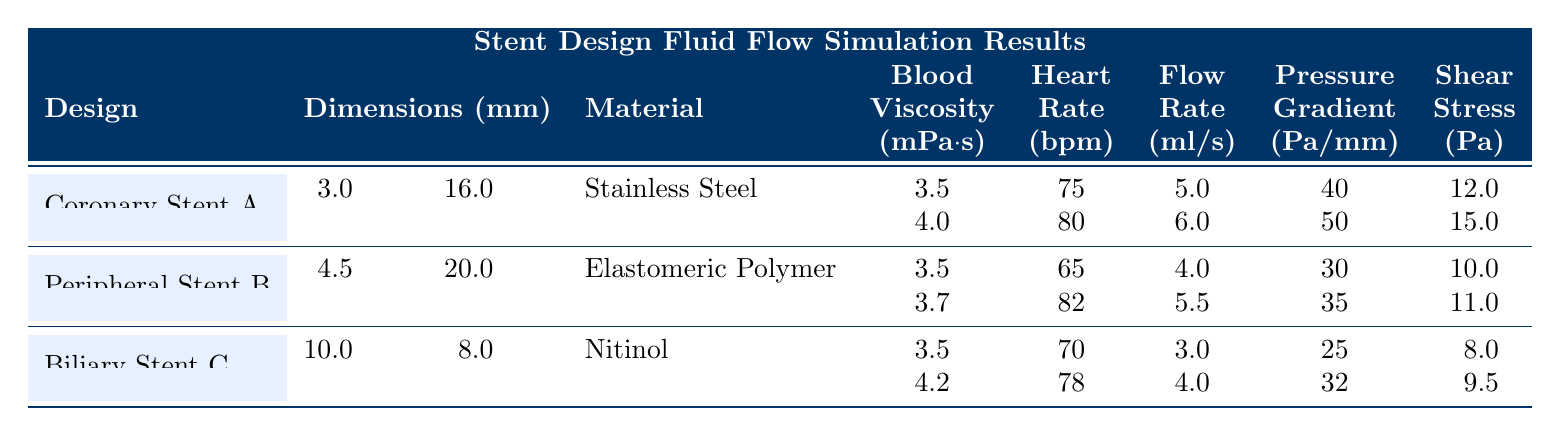What is the diameter of Biliary Stent C? The diameter of Biliary Stent C is listed in the dimensions section of the table, which shows the dimensions for each stent design. Specifically, it states "diameter_mm: 10.0" for Biliary Stent C.
Answer: 10.0 mm What material is used for Peripheral Stent B? Peripheral Stent B has its material specified as "Elastomeric Polymer" in the material column of the table.
Answer: Elastomeric Polymer What is the flow rate for Coronary Stent A under a blood viscosity of 4.0 mPa·s? Coronary Stent A has a condition listed with a blood viscosity of 4.0 mPa·s, with the flow rate being shown in the corresponding row. It states the flow rate as "6.0 ml/s."
Answer: 6.0 ml/s What is the average shear stress for all stent designs? To find the average shear stress, we need to sum the shear stress values across all conditions and divide by the number of conditions. The total shear stress values are 12.0 + 15.0 + 10.0 + 11.0 + 8.0 + 9.5 = 66.5 and there are 6 conditions. Thus, the average shear stress is 66.5 / 6 = 11.08.
Answer: 11.08 Pa Is the heart rate for the second condition of Peripheral Stent B higher than 75 bpm? The heart rate for the second condition of Peripheral Stent B is 82 bpm, which can be compared to 75 bpm from the question. Since 82 is greater than 75, the answer is yes.
Answer: Yes Which stent design has the highest pressure gradient? To determine the highest pressure gradient, we need to examine the pressure gradient values for each design. The values are 40, 50 (Coronary Stent A), 30, 35 (Peripheral Stent B), and 25, 32 (Biliary Stent C). The maximum value among these is 50 for Coronary Stent A.
Answer: Coronary Stent A How many different blood viscosity conditions are tested for Biliary Stent C? Biliary Stent C has two conditions listed in the table, each with its respective blood viscosity values. This indicates that two different viscosity conditions were tested.
Answer: 2 What is the pressure gradient for the first condition of Coronary Stent A? The first condition for Coronary Stent A states that the pressure gradient is "40 Pa/mm," which can be directly referenced from the corresponding entry in the table.
Answer: 40 Pa/mm Does Peripheral Stent B have a higher shear stress in its second condition than the first? The shear stress in the first condition for Peripheral Stent B is 10.0 Pa while in the second condition it is 11.0 Pa. Since 11.0 is greater than 10.0, the answer is yes.
Answer: Yes 